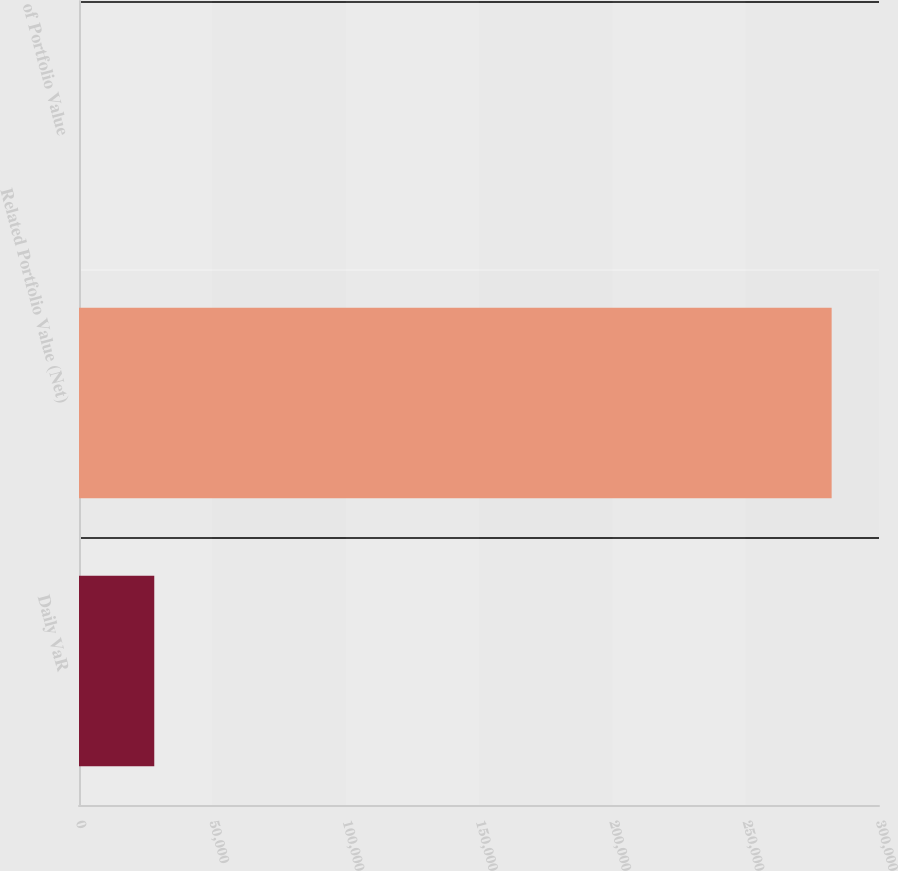Convert chart to OTSL. <chart><loc_0><loc_0><loc_500><loc_500><bar_chart><fcel>Daily VaR<fcel>Related Portfolio Value (Net)<fcel>of Portfolio Value<nl><fcel>28224.1<fcel>282240<fcel>0.08<nl></chart> 